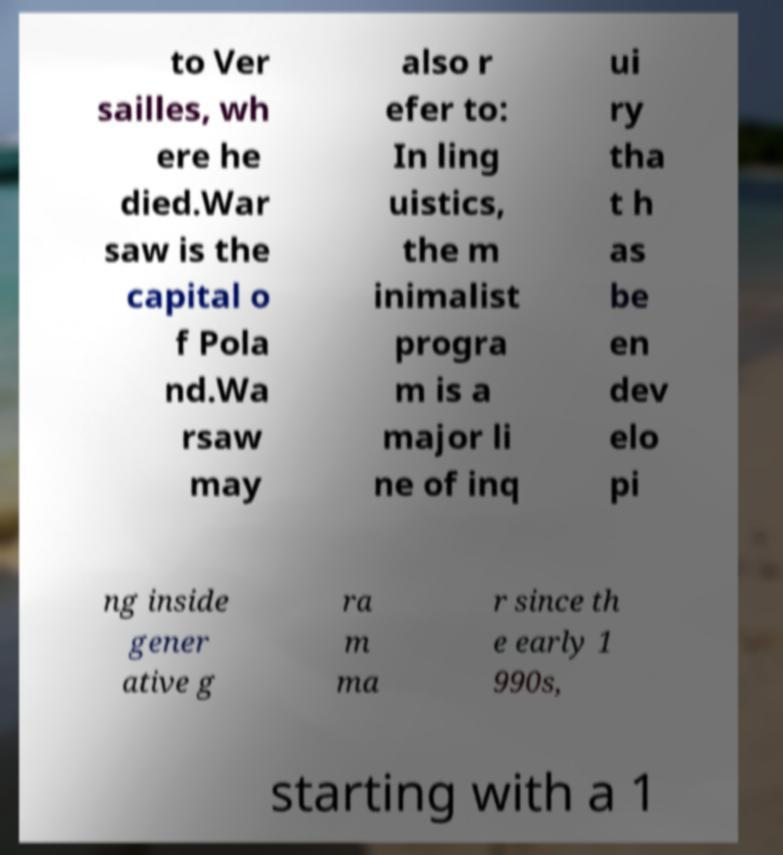There's text embedded in this image that I need extracted. Can you transcribe it verbatim? to Ver sailles, wh ere he died.War saw is the capital o f Pola nd.Wa rsaw may also r efer to: In ling uistics, the m inimalist progra m is a major li ne of inq ui ry tha t h as be en dev elo pi ng inside gener ative g ra m ma r since th e early 1 990s, starting with a 1 